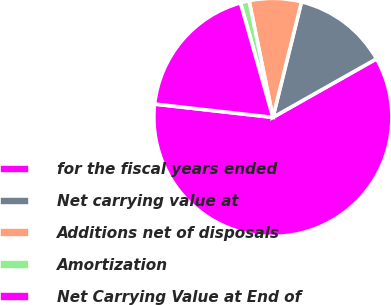Convert chart. <chart><loc_0><loc_0><loc_500><loc_500><pie_chart><fcel>for the fiscal years ended<fcel>Net carrying value at<fcel>Additions net of disposals<fcel>Amortization<fcel>Net Carrying Value at End of<nl><fcel>59.97%<fcel>12.95%<fcel>7.07%<fcel>1.19%<fcel>18.82%<nl></chart> 